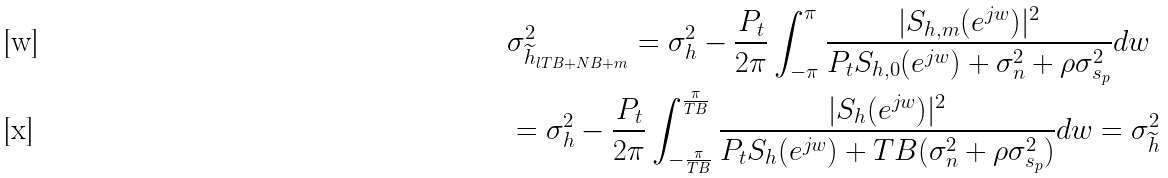<formula> <loc_0><loc_0><loc_500><loc_500>& \sigma _ { \widetilde { h } _ { l T B + N B + m } } ^ { 2 } = \sigma _ { h } ^ { 2 } - \frac { P _ { t } } { 2 \pi } \int _ { - \pi } ^ { \pi } \frac { | S _ { h , m } ( e ^ { j w } ) | ^ { 2 } } { P _ { t } S _ { h , 0 } ( e ^ { j w } ) + \sigma _ { n } ^ { 2 } + \rho \sigma _ { s _ { p } } ^ { 2 } } d w \\ & = \sigma _ { h } ^ { 2 } - \frac { P _ { t } } { 2 \pi } \int _ { - \frac { \pi } { T B } } ^ { \frac { \pi } { T B } } \frac { | S _ { h } ( e ^ { j w } ) | ^ { 2 } } { P _ { t } S _ { h } ( e ^ { j w } ) + T B ( \sigma _ { n } ^ { 2 } + \rho \sigma _ { s _ { p } } ^ { 2 } ) } d w = \sigma _ { \widetilde { h } } ^ { 2 }</formula> 